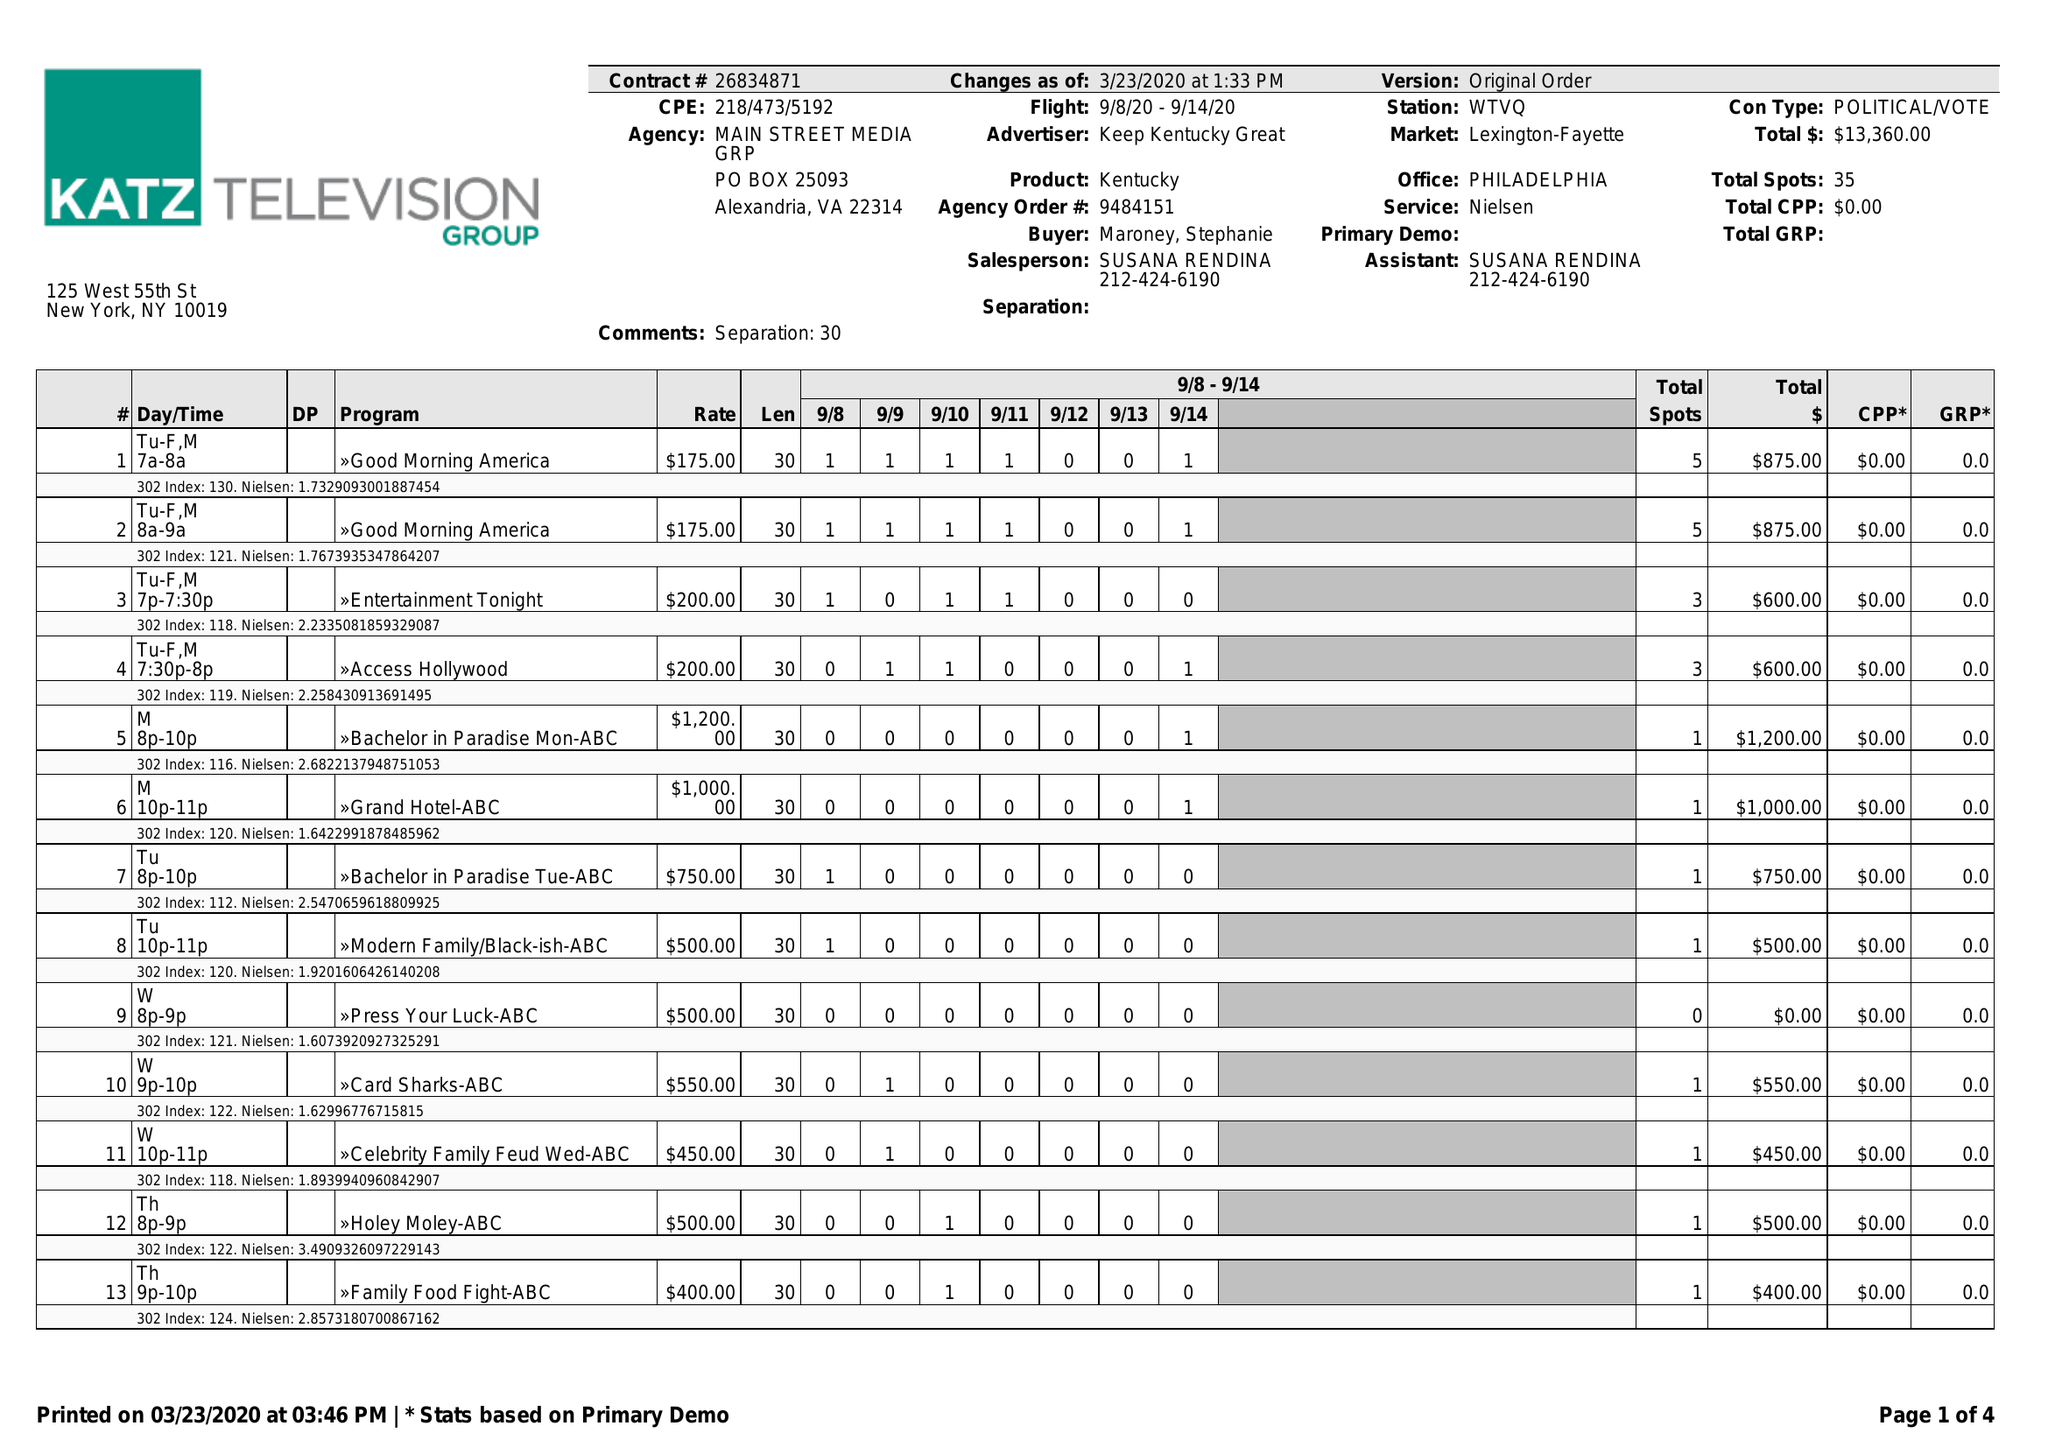What is the value for the flight_to?
Answer the question using a single word or phrase. 09/14/20 